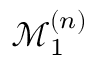<formula> <loc_0><loc_0><loc_500><loc_500>\mathcal { M } _ { 1 } ^ { ( n ) }</formula> 